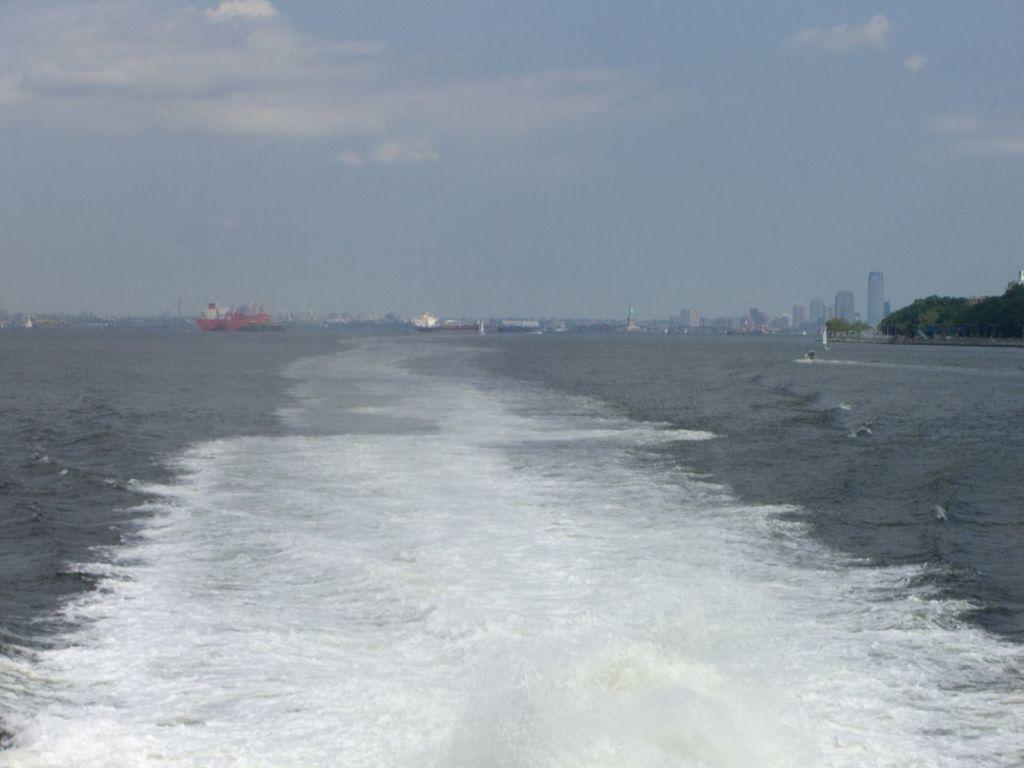Please provide a concise description of this image. In this image there is the sky towards the top of the image, there are clouds in the sky, there are buildings, there are trees towards the right of the image, there is the sea. 